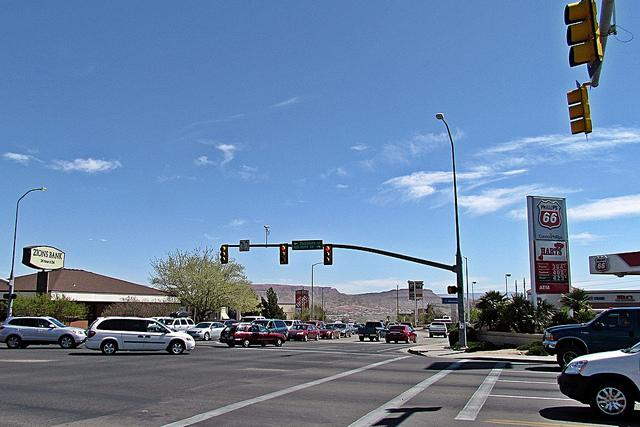What type of station is nearby? gas 